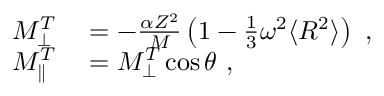Convert formula to latex. <formula><loc_0><loc_0><loc_500><loc_500>\begin{array} { r l } { M _ { \perp } ^ { T } } & = - \frac { \alpha Z ^ { 2 } } { M } \left ( 1 - \frac { 1 } { 3 } \omega ^ { 2 } \langle R ^ { 2 } \rangle \right ) , } \\ { M _ { \| } ^ { T } } & = M _ { \perp } ^ { T } \cos \theta , } \end{array}</formula> 